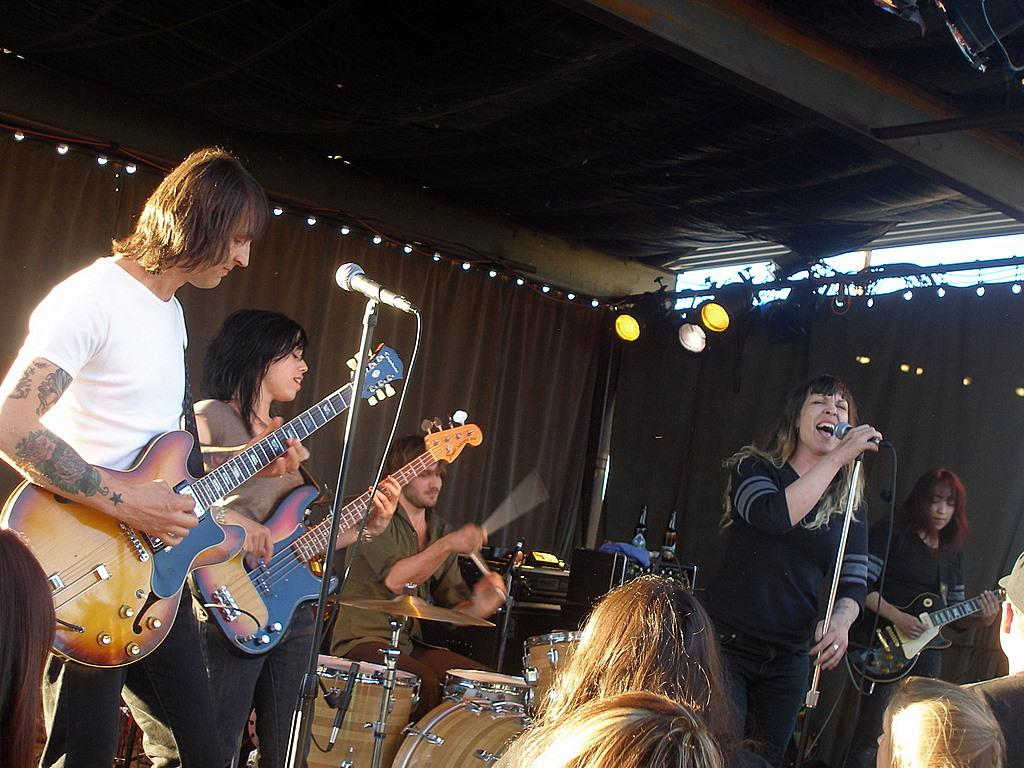What type of performance is taking place in the image? There is a rock band performing in the image. Who is present to watch the performance? People are watching the performance. Can you see an airplane flying over the rock band in the image? There is no airplane visible in the image; it only features a rock band performing and people watching the performance. What type of debt is being discussed by the rock band in the image? There is no mention or indication of any debt being discussed in the image. 